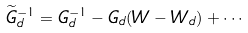Convert formula to latex. <formula><loc_0><loc_0><loc_500><loc_500>\widetilde { G } _ { d } ^ { - 1 } = G _ { d } ^ { - 1 } - G _ { d } ( W - W _ { d } ) + \cdots</formula> 